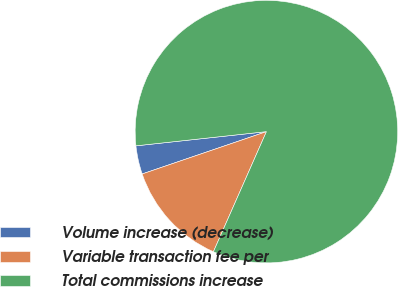Convert chart. <chart><loc_0><loc_0><loc_500><loc_500><pie_chart><fcel>Volume increase (decrease)<fcel>Variable transaction fee per<fcel>Total commissions increase<nl><fcel>3.5%<fcel>13.16%<fcel>83.35%<nl></chart> 